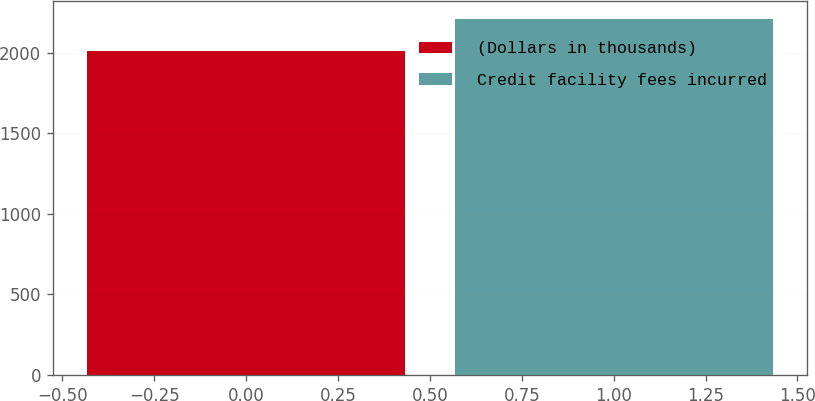Convert chart. <chart><loc_0><loc_0><loc_500><loc_500><bar_chart><fcel>(Dollars in thousands)<fcel>Credit facility fees incurred<nl><fcel>2011<fcel>2211<nl></chart> 